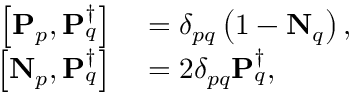Convert formula to latex. <formula><loc_0><loc_0><loc_500><loc_500>\begin{array} { r l } { \left [ P _ { p } , P _ { q } ^ { \dagger } \right ] } & = \delta _ { p q } \left ( 1 - N _ { q } \right ) , } \\ { \left [ N _ { p } , P _ { q } ^ { \dagger } \right ] } & = 2 \delta _ { p q } P _ { q } ^ { \dagger } , } \end{array}</formula> 